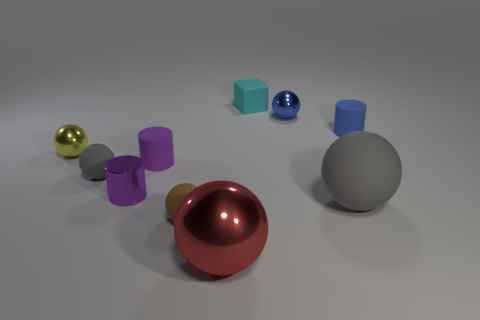Subtract all brown spheres. How many spheres are left? 5 Subtract all brown balls. How many balls are left? 5 Subtract all brown cylinders. Subtract all cyan balls. How many cylinders are left? 3 Subtract all balls. How many objects are left? 4 Subtract all big metallic balls. Subtract all red objects. How many objects are left? 8 Add 4 small purple rubber objects. How many small purple rubber objects are left? 5 Add 6 large metallic balls. How many large metallic balls exist? 7 Subtract 0 gray cylinders. How many objects are left? 10 